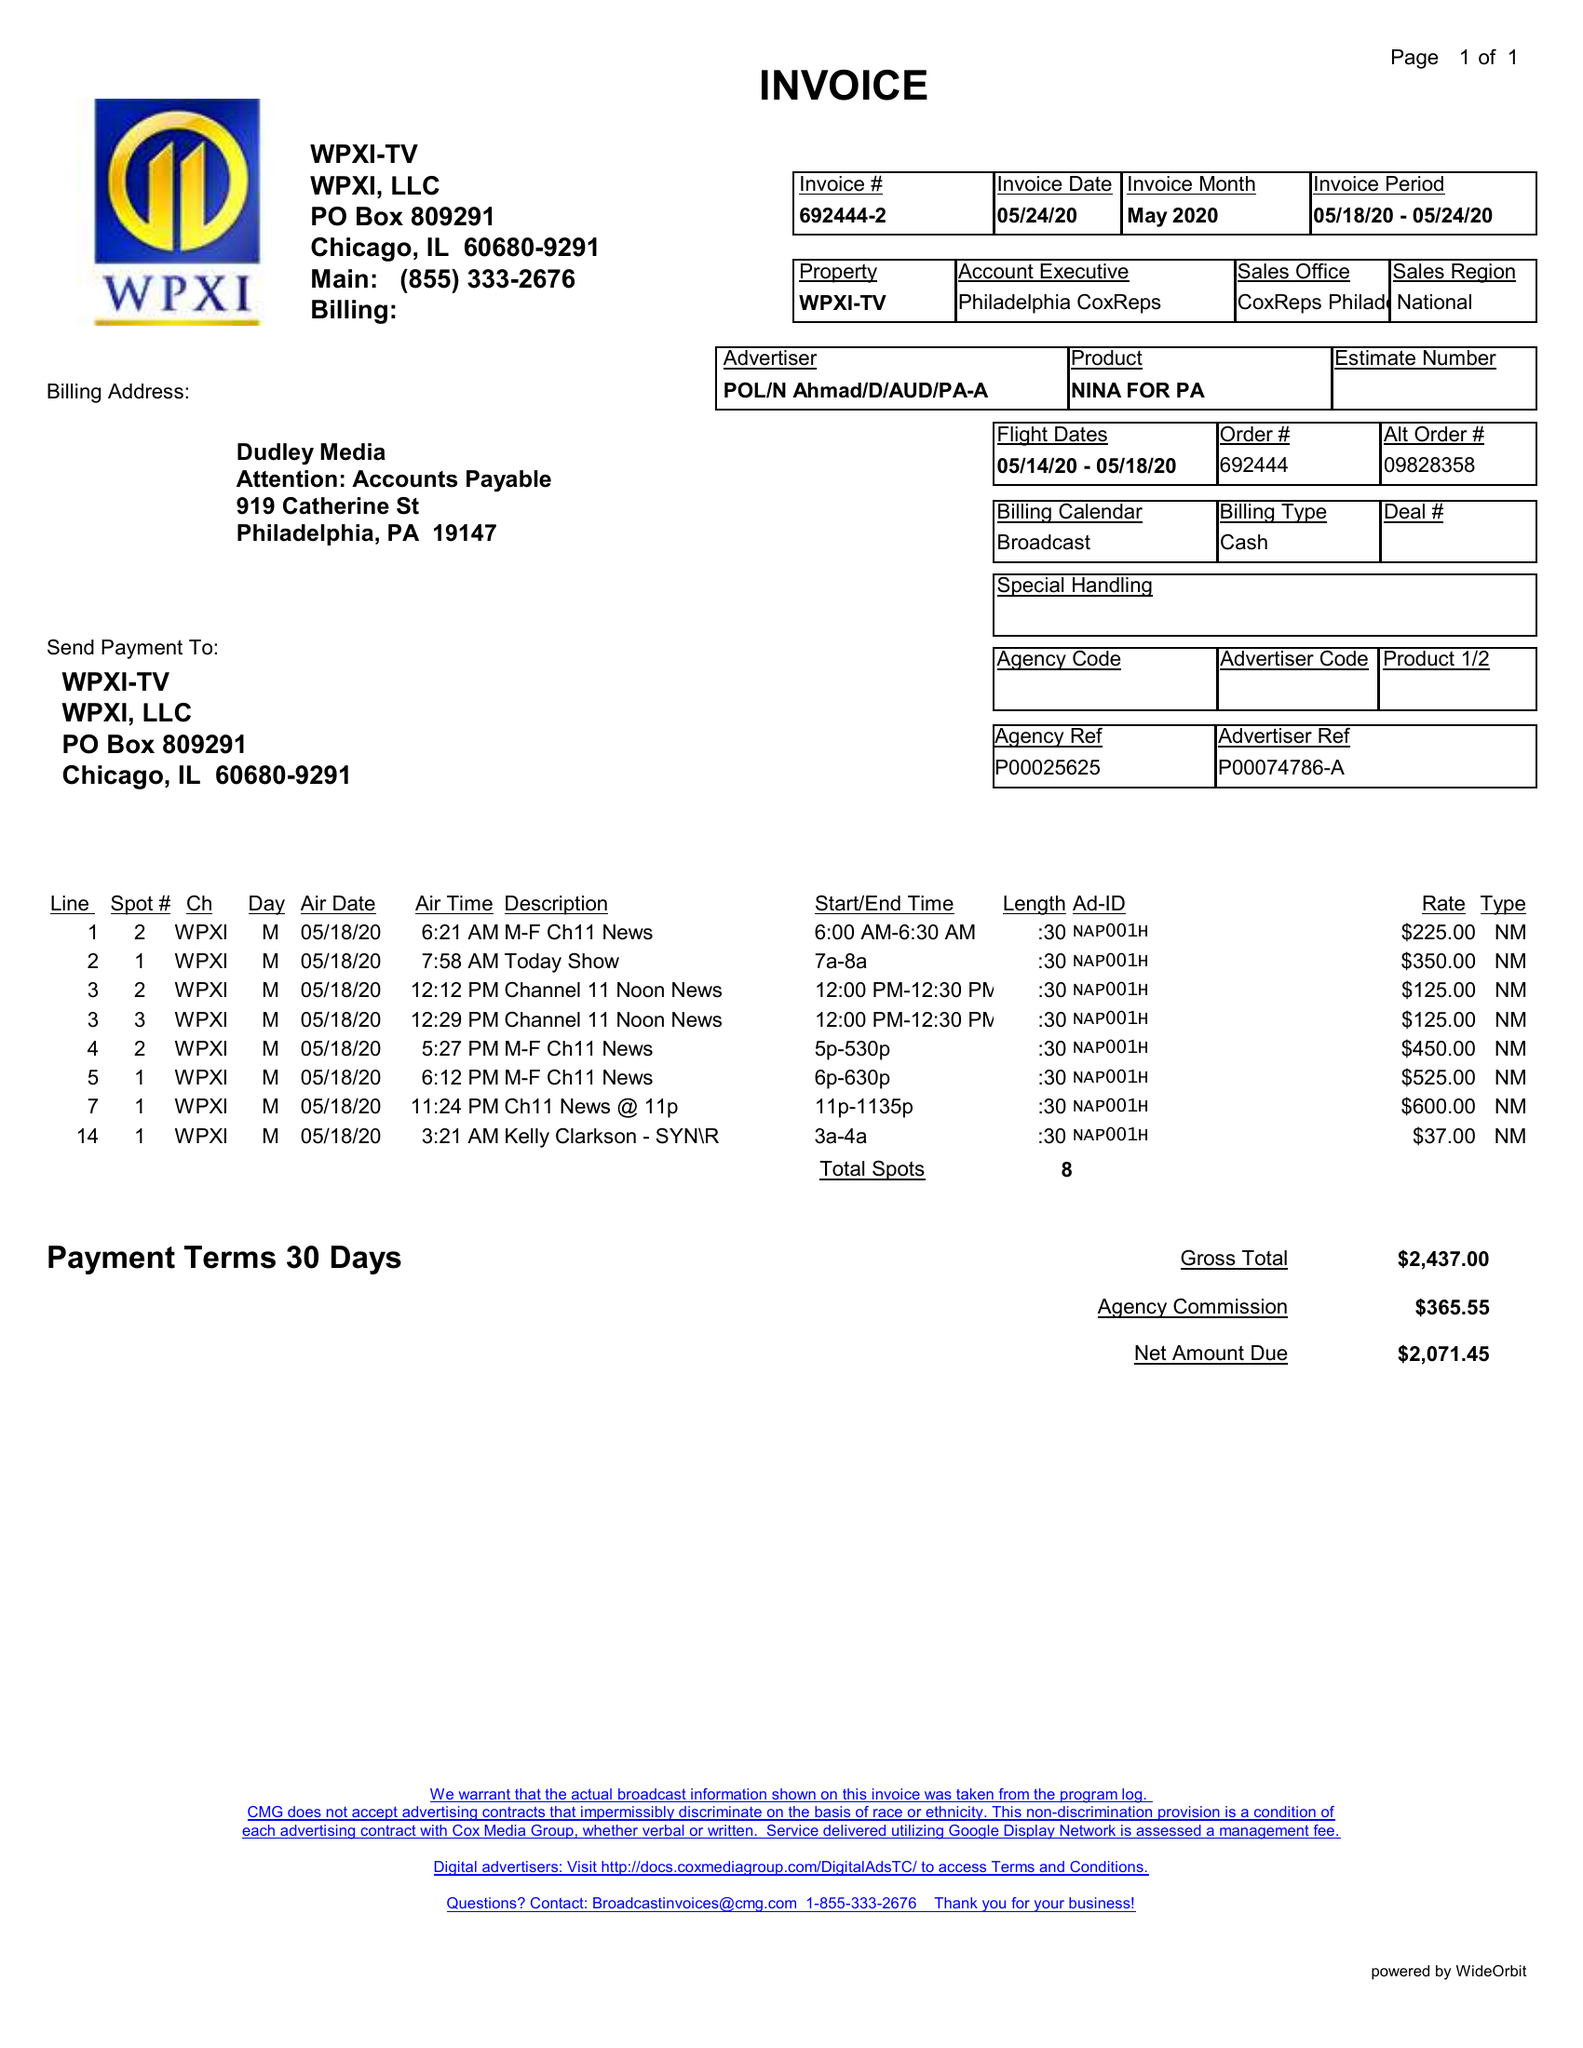What is the value for the contract_num?
Answer the question using a single word or phrase. 692444 